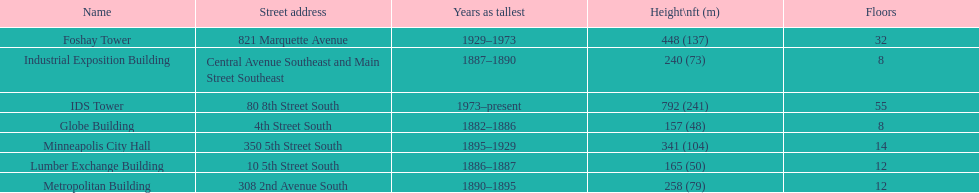Which building has 8 floors and is 240 ft tall? Industrial Exposition Building. 